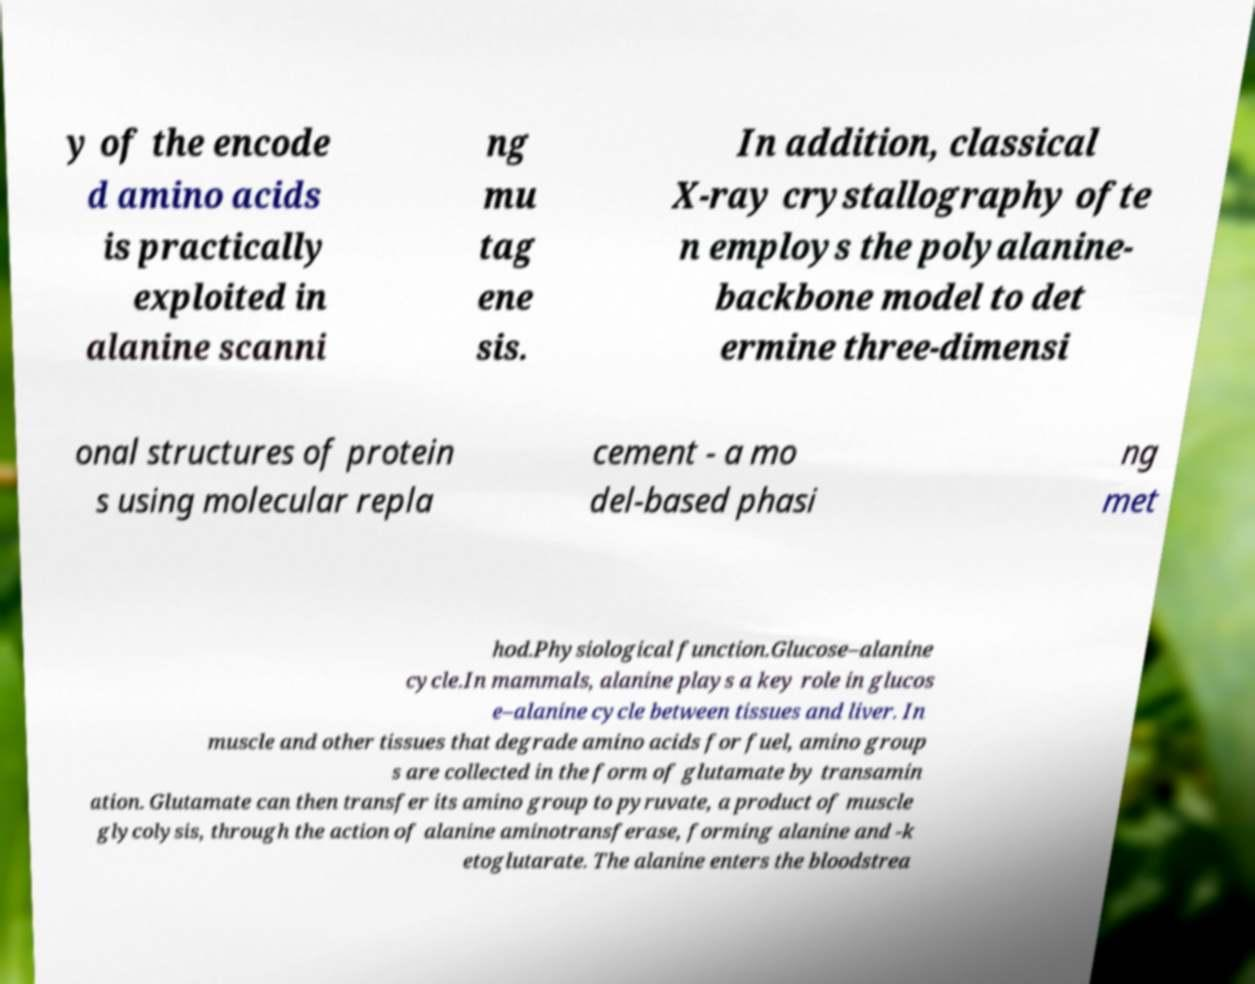Can you read and provide the text displayed in the image?This photo seems to have some interesting text. Can you extract and type it out for me? y of the encode d amino acids is practically exploited in alanine scanni ng mu tag ene sis. In addition, classical X-ray crystallography ofte n employs the polyalanine- backbone model to det ermine three-dimensi onal structures of protein s using molecular repla cement - a mo del-based phasi ng met hod.Physiological function.Glucose–alanine cycle.In mammals, alanine plays a key role in glucos e–alanine cycle between tissues and liver. In muscle and other tissues that degrade amino acids for fuel, amino group s are collected in the form of glutamate by transamin ation. Glutamate can then transfer its amino group to pyruvate, a product of muscle glycolysis, through the action of alanine aminotransferase, forming alanine and -k etoglutarate. The alanine enters the bloodstrea 